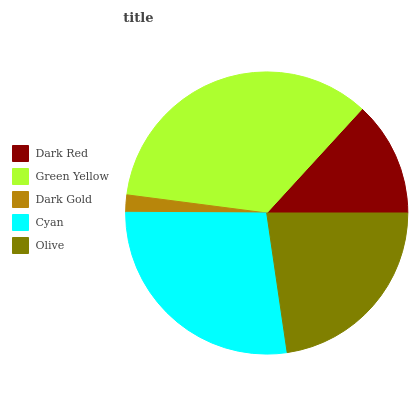Is Dark Gold the minimum?
Answer yes or no. Yes. Is Green Yellow the maximum?
Answer yes or no. Yes. Is Green Yellow the minimum?
Answer yes or no. No. Is Dark Gold the maximum?
Answer yes or no. No. Is Green Yellow greater than Dark Gold?
Answer yes or no. Yes. Is Dark Gold less than Green Yellow?
Answer yes or no. Yes. Is Dark Gold greater than Green Yellow?
Answer yes or no. No. Is Green Yellow less than Dark Gold?
Answer yes or no. No. Is Olive the high median?
Answer yes or no. Yes. Is Olive the low median?
Answer yes or no. Yes. Is Dark Gold the high median?
Answer yes or no. No. Is Cyan the low median?
Answer yes or no. No. 